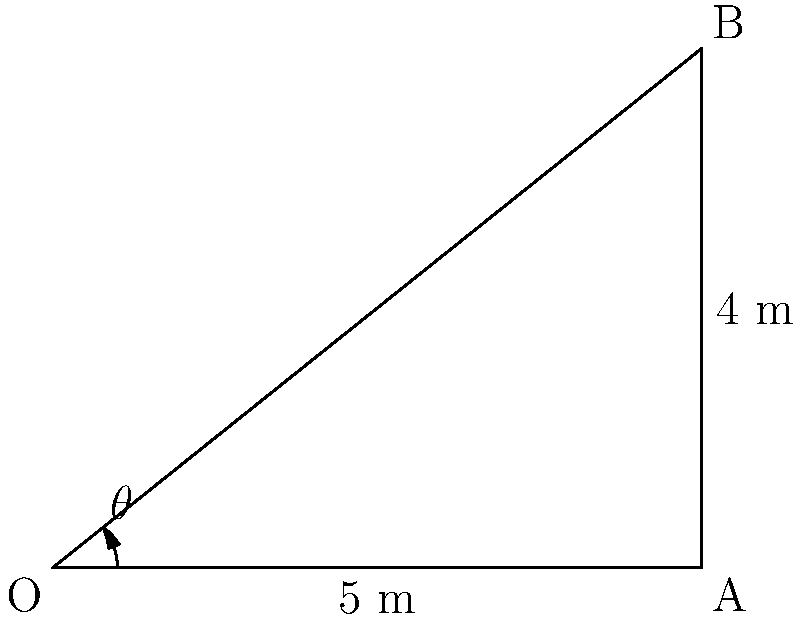In the upcoming match against our rivals, our star striker is about to take a crucial free kick. The ball needs to clear a wall of defenders 5 meters away and reach a height of 4 meters. What's the minimum angle $\theta$ (in degrees) at which the ball must be kicked to achieve this trajectory? Let's approach this step-by-step:

1) The situation can be represented by a right-angled triangle, where:
   - The horizontal distance to the wall is 5 meters (adjacent side)
   - The height the ball needs to reach is 4 meters (opposite side)
   - The angle $\theta$ is what we need to find

2) In a right-angled triangle, the tangent of an angle is the ratio of the opposite side to the adjacent side:

   $\tan \theta = \frac{\text{opposite}}{\text{adjacent}}$

3) Substituting our values:

   $\tan \theta = \frac{4}{5}$

4) To find $\theta$, we need to use the inverse tangent (arctan or $\tan^{-1}$):

   $\theta = \tan^{-1}(\frac{4}{5})$

5) Using a calculator or mathematical tables:

   $\theta \approx 38.66°$

6) Rounding to one decimal place:

   $\theta \approx 38.7°$

This is the minimum angle required. In a real match, our striker might aim a bit higher to account for factors like air resistance and to ensure clearing the wall.
Answer: $38.7°$ 